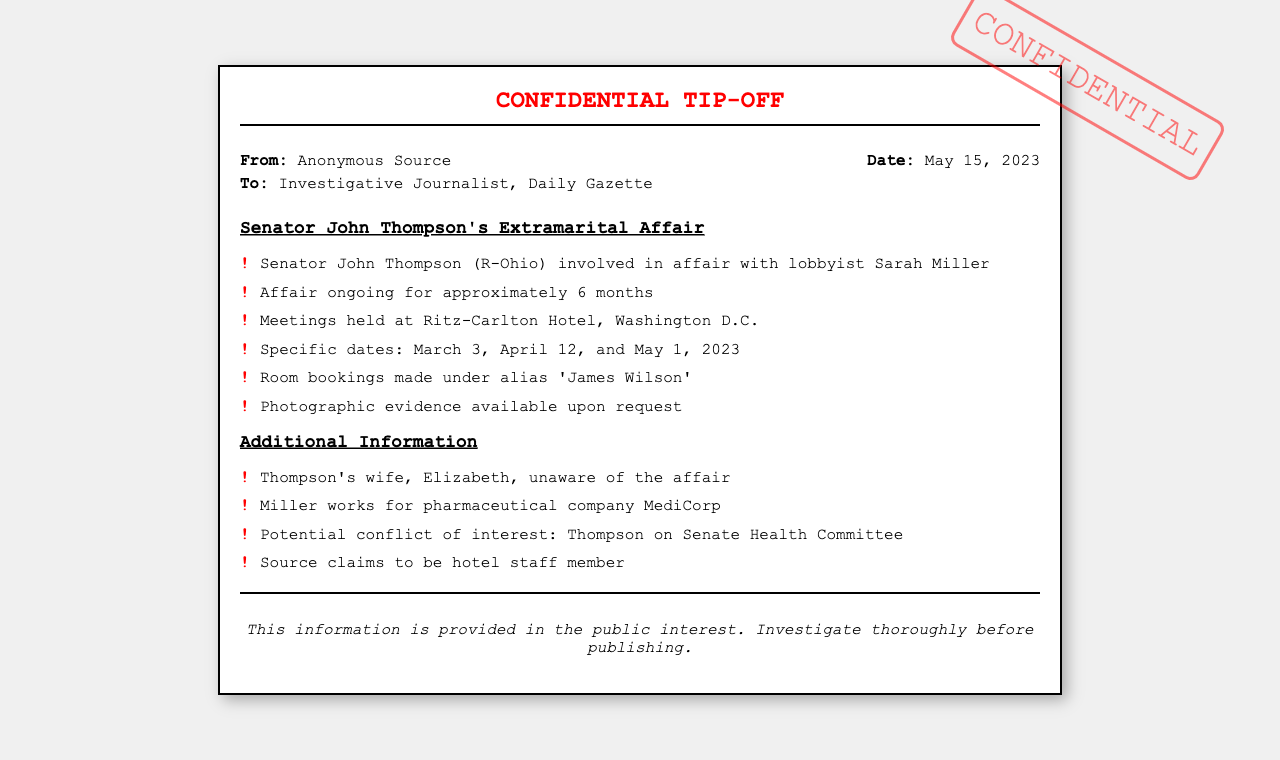What is the name of the Senator involved? The document specifies that the Senator involved in the extramarital affair is John Thompson.
Answer: John Thompson What is the name of the lobbyist? The document mentions that the lobbyist involved in the affair is Sarah Miller.
Answer: Sarah Miller When did the affair reportedly start? The document states that the affair has been ongoing for approximately 6 months, suggesting it started around November 2022.
Answer: November 2022 Where were the meetings held? The document indicates that the meetings took place at the Ritz-Carlton Hotel, Washington D.C.
Answer: Ritz-Carlton Hotel, Washington D.C How many specific meeting dates are mentioned? The document lists three specific meeting dates: March 3, April 12, and May 1, 2023.
Answer: Three What alias was used for room bookings? According to the document, the room bookings were made under the alias 'James Wilson'.
Answer: James Wilson What is Senator Thompson's wife's name? The document identifies Senator Thompson's wife as Elizabeth.
Answer: Elizabeth Which committee is Senator Thompson on? The document specifies that Senator Thompson is on the Senate Health Committee.
Answer: Senate Health Committee Who provided the tip-off? The document indicates that the tip-off was provided by an anonymous source.
Answer: Anonymous Source 